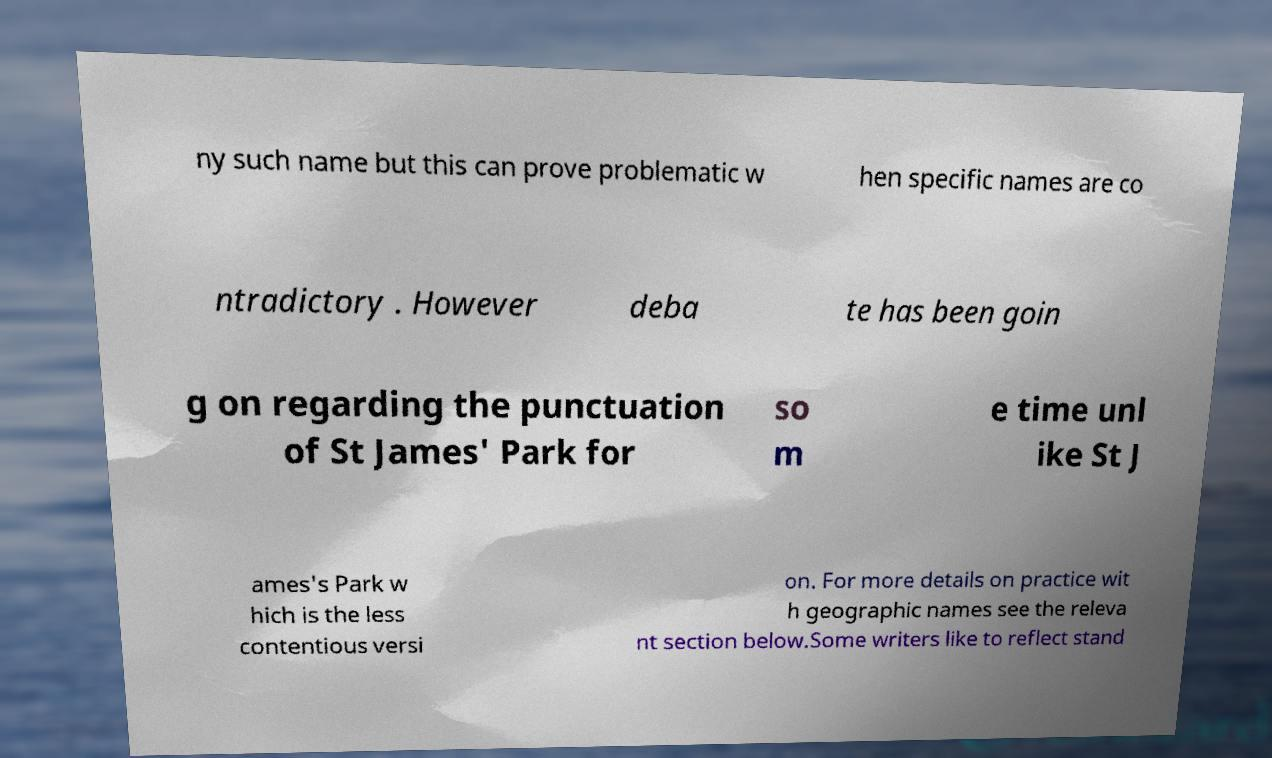Can you read and provide the text displayed in the image?This photo seems to have some interesting text. Can you extract and type it out for me? ny such name but this can prove problematic w hen specific names are co ntradictory . However deba te has been goin g on regarding the punctuation of St James' Park for so m e time unl ike St J ames's Park w hich is the less contentious versi on. For more details on practice wit h geographic names see the releva nt section below.Some writers like to reflect stand 